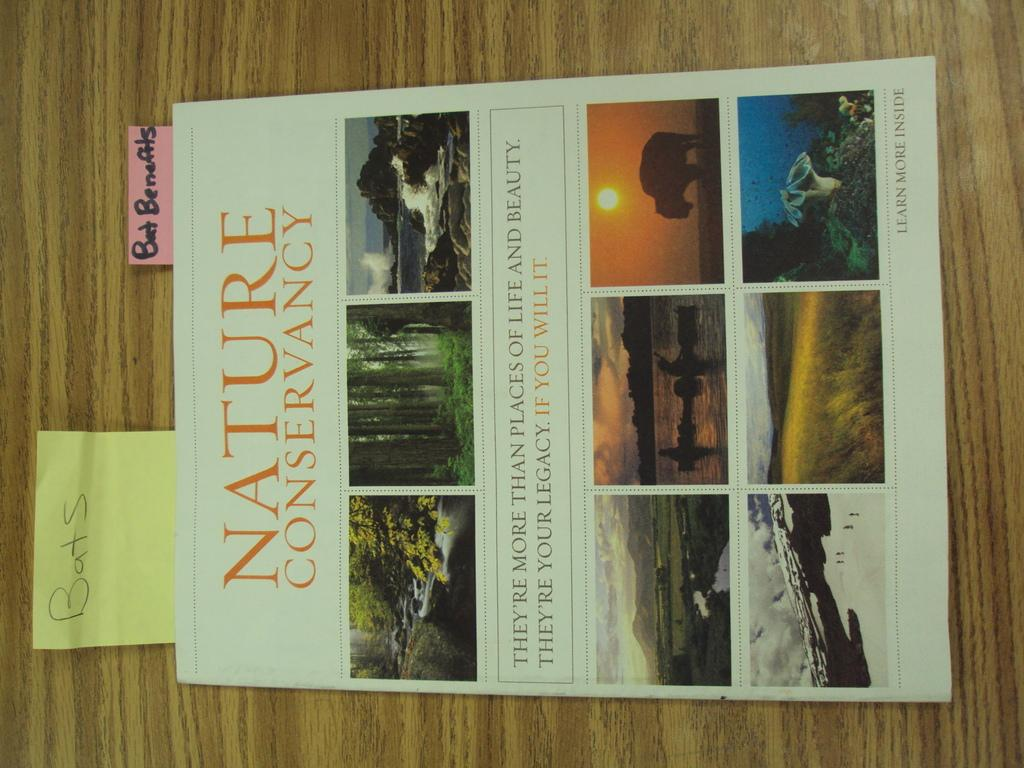Provide a one-sentence caption for the provided image. A flyer for nature conservancy with a sticky note attached saying bats. 